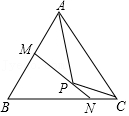Can you explain why M and N are positioned on the perpendicular bisectors of AP and CP respectively? M and N lying on the perpendicular bisectors of AP and CP respectively suggest that each of these points is equidistant from the ends of the corresponding line segments. This characteristic is a defining property of the circumcenter of a triangle, which is the center of the circumcircle passing through all three vertices of the triangle. Thus, this geometric configuration might imply that point P is the circumcenter, positioning M and N strategically to reflect symmetry and balance within the triangle. 